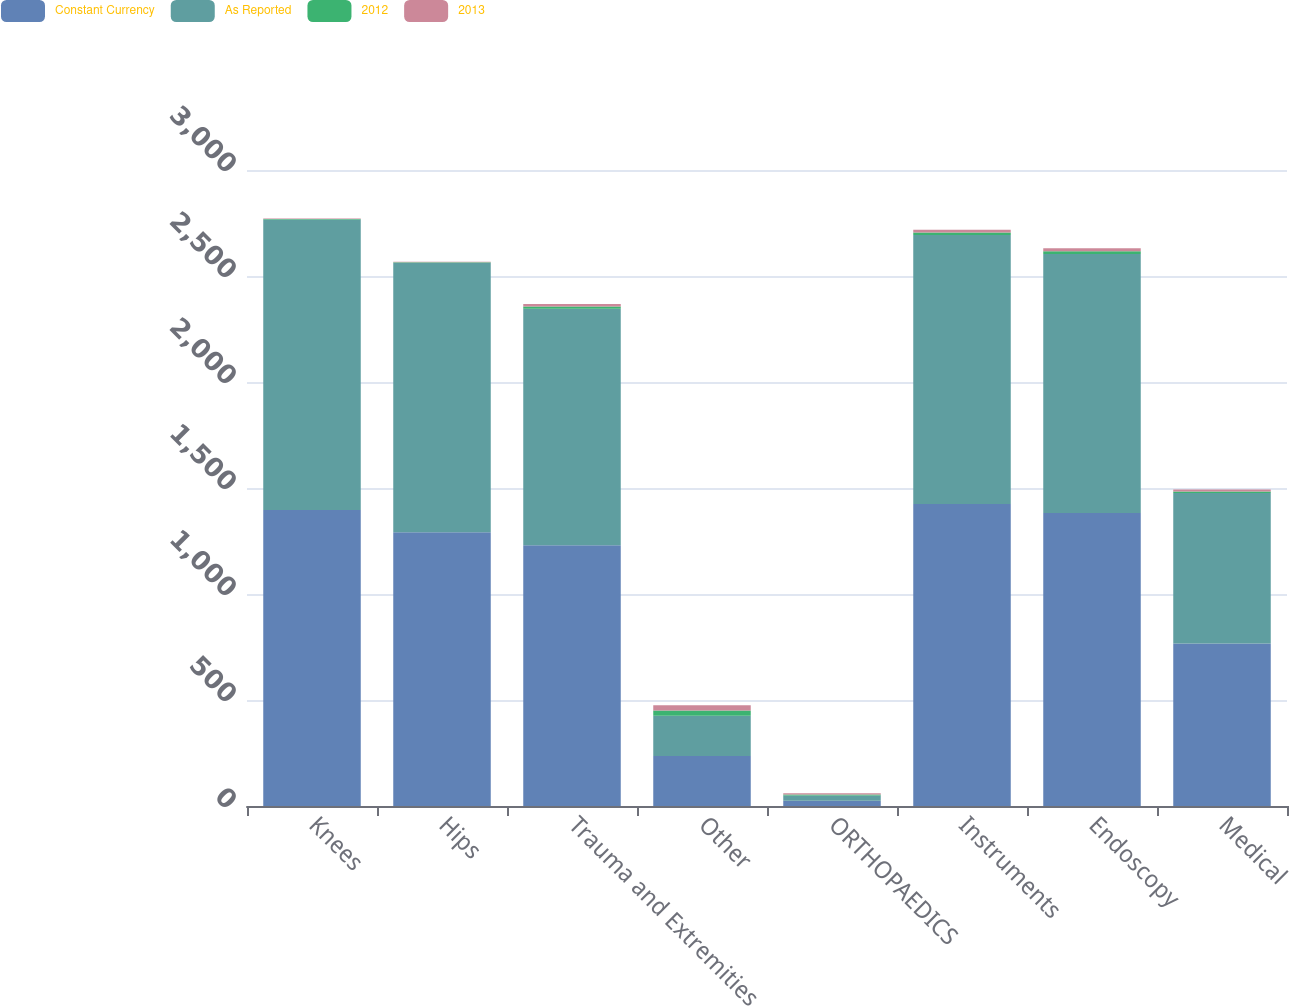Convert chart. <chart><loc_0><loc_0><loc_500><loc_500><stacked_bar_chart><ecel><fcel>Knees<fcel>Hips<fcel>Trauma and Extremities<fcel>Other<fcel>ORTHOPAEDICS<fcel>Instruments<fcel>Endoscopy<fcel>Medical<nl><fcel>Constant Currency<fcel>1396<fcel>1291<fcel>1230<fcel>236<fcel>24.6<fcel>1424<fcel>1382<fcel>766<nl><fcel>As Reported<fcel>1371<fcel>1272<fcel>1116<fcel>190<fcel>24.6<fcel>1269<fcel>1222<fcel>710<nl><fcel>2012<fcel>1.8<fcel>1.5<fcel>10.2<fcel>24<fcel>5.2<fcel>12.2<fcel>13.1<fcel>7.9<nl><fcel>2013<fcel>2.7<fcel>2.7<fcel>11.4<fcel>25.2<fcel>6.3<fcel>13.1<fcel>14.2<fcel>8.8<nl></chart> 